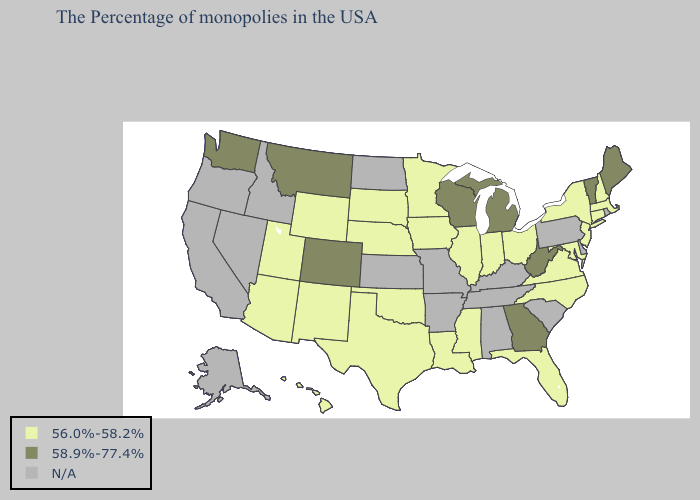What is the lowest value in the USA?
Be succinct. 56.0%-58.2%. What is the lowest value in states that border Kansas?
Keep it brief. 56.0%-58.2%. Does Washington have the highest value in the USA?
Keep it brief. Yes. Which states have the lowest value in the USA?
Answer briefly. Massachusetts, New Hampshire, Connecticut, New York, New Jersey, Maryland, Virginia, North Carolina, Ohio, Florida, Indiana, Illinois, Mississippi, Louisiana, Minnesota, Iowa, Nebraska, Oklahoma, Texas, South Dakota, Wyoming, New Mexico, Utah, Arizona, Hawaii. Among the states that border Massachusetts , does Vermont have the lowest value?
Quick response, please. No. Among the states that border New York , does Massachusetts have the lowest value?
Quick response, please. Yes. Among the states that border Iowa , does Wisconsin have the highest value?
Concise answer only. Yes. Among the states that border Pennsylvania , which have the lowest value?
Keep it brief. New York, New Jersey, Maryland, Ohio. Name the states that have a value in the range 56.0%-58.2%?
Give a very brief answer. Massachusetts, New Hampshire, Connecticut, New York, New Jersey, Maryland, Virginia, North Carolina, Ohio, Florida, Indiana, Illinois, Mississippi, Louisiana, Minnesota, Iowa, Nebraska, Oklahoma, Texas, South Dakota, Wyoming, New Mexico, Utah, Arizona, Hawaii. Among the states that border Wyoming , which have the lowest value?
Answer briefly. Nebraska, South Dakota, Utah. What is the highest value in the USA?
Quick response, please. 58.9%-77.4%. Is the legend a continuous bar?
Be succinct. No. Does Washington have the lowest value in the West?
Answer briefly. No. What is the value of Maine?
Answer briefly. 58.9%-77.4%. 